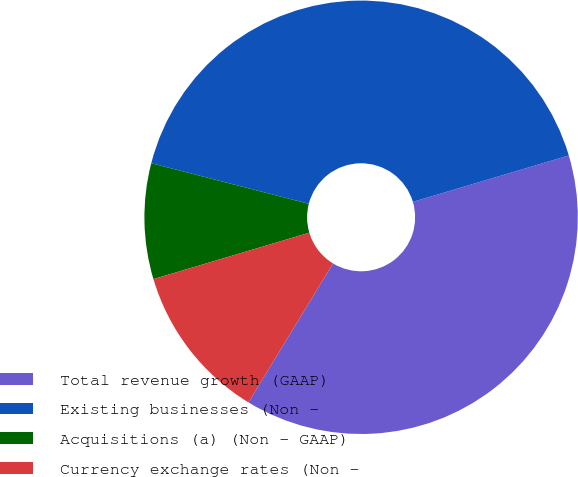<chart> <loc_0><loc_0><loc_500><loc_500><pie_chart><fcel>Total revenue growth (GAAP)<fcel>Existing businesses (Non -<fcel>Acquisitions (a) (Non - GAAP)<fcel>Currency exchange rates (Non -<nl><fcel>38.31%<fcel>41.38%<fcel>8.62%<fcel>11.69%<nl></chart> 